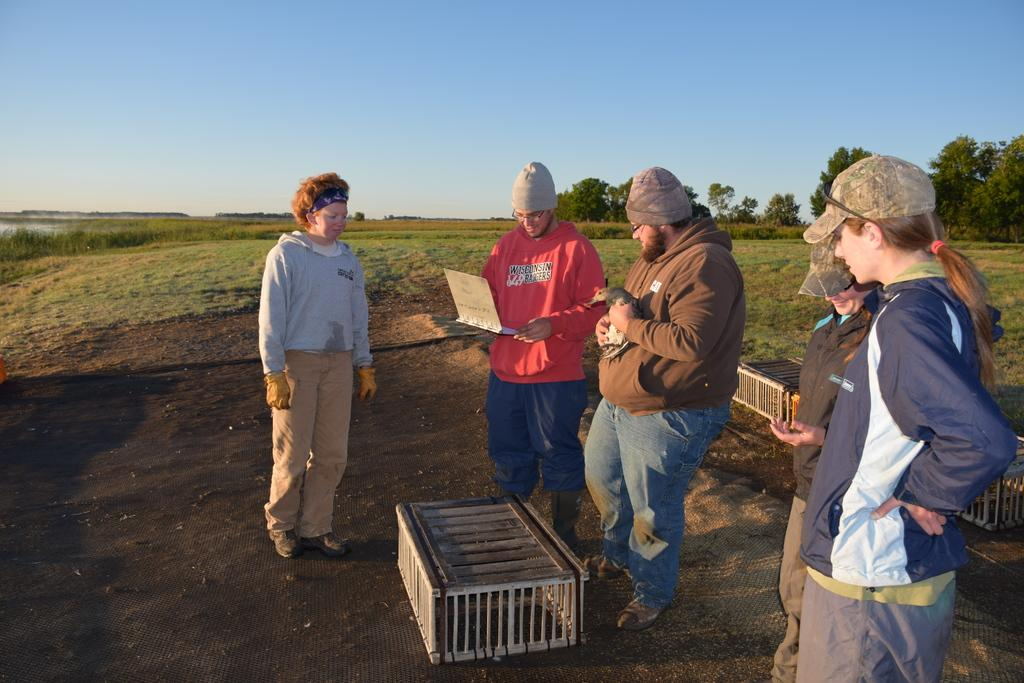What are the people in the image doing? The people in the image are standing. What object is the man holding in the image? The man is holding a laptop in the image. What type of objects can be seen in the image? There are wooden objects visible in the image. What can be seen in the background of the image? Grass, trees, and plants are visible in the background of the image. What is the color of the sky in the image? The sky is blue in color in the image. How many pins are holding up the bath in the image? There is no bath present in the image, so there are no pins holding it up. 